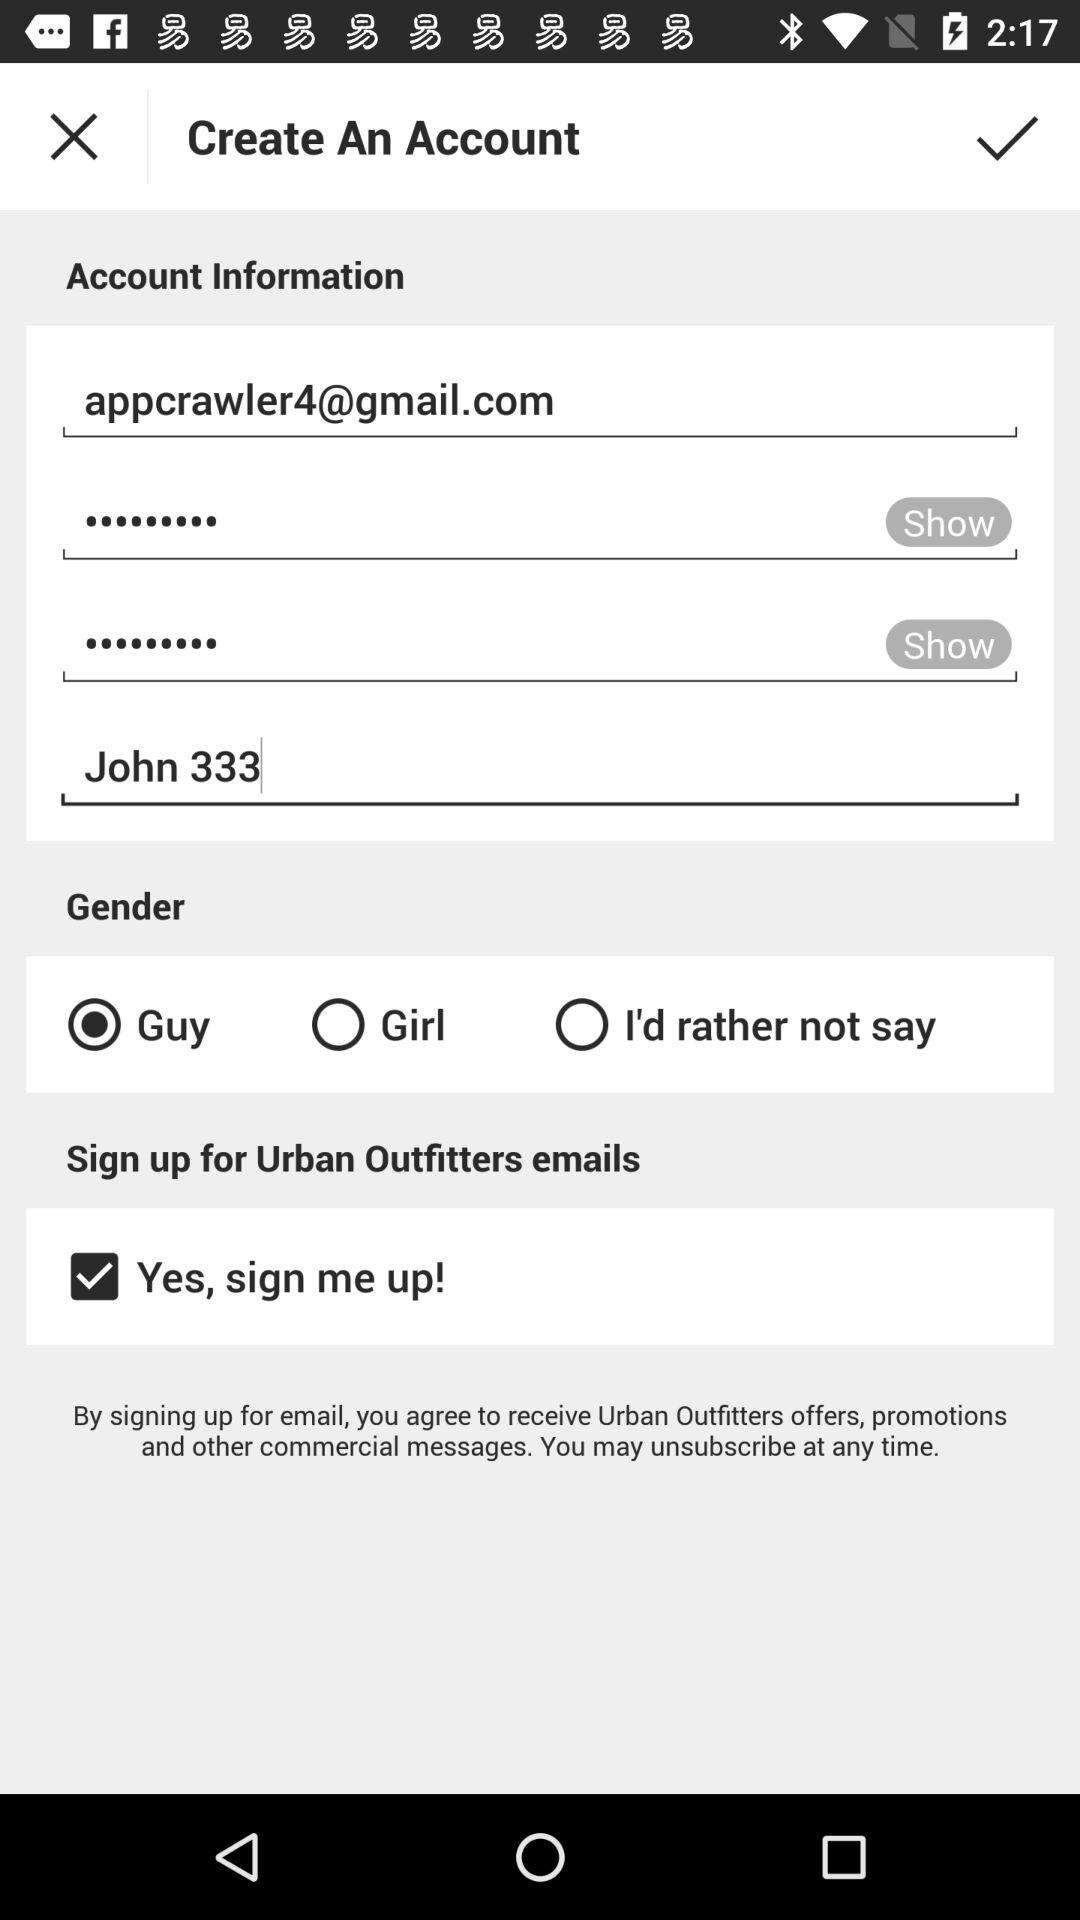What is the user name? The user name is John 333. 